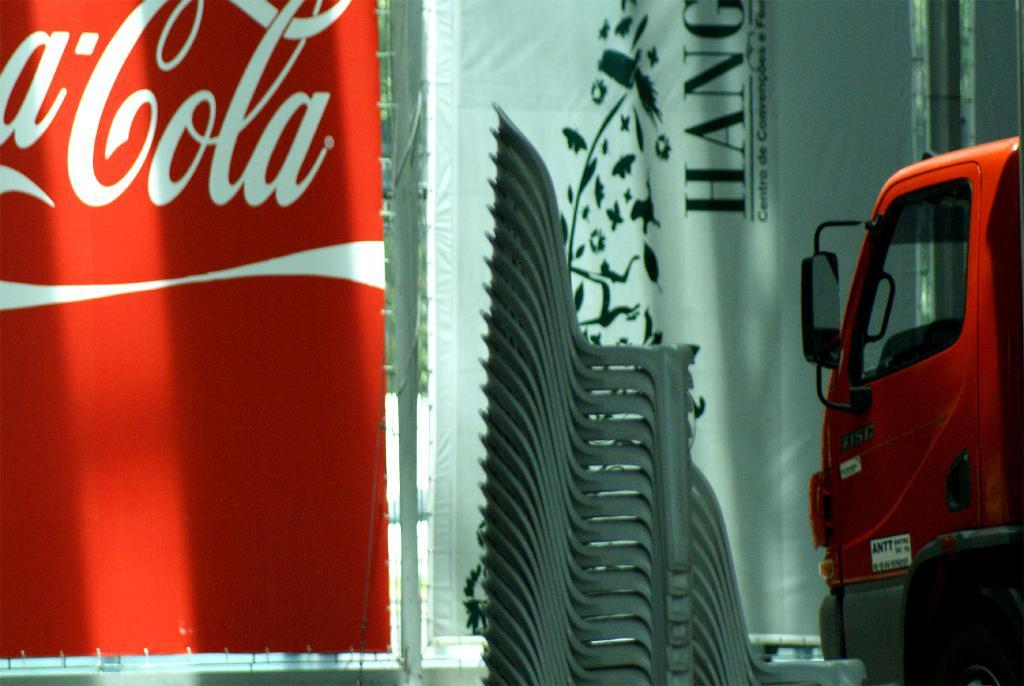What is on the left side of the image? There is a red banner on the left side of the image. What can be seen in the middle of the image? There are chairs in the middle of the image. What is on the right side of the image? There is a vehicle on the right side of the image. How many geese are sitting on the red banner in the image? There are no geese present in the image; it features a red banner, chairs, and a vehicle. What type of finger can be seen interacting with the vehicle in the image? There are no fingers visible in the image; it only shows a red banner, chairs, and a vehicle. 